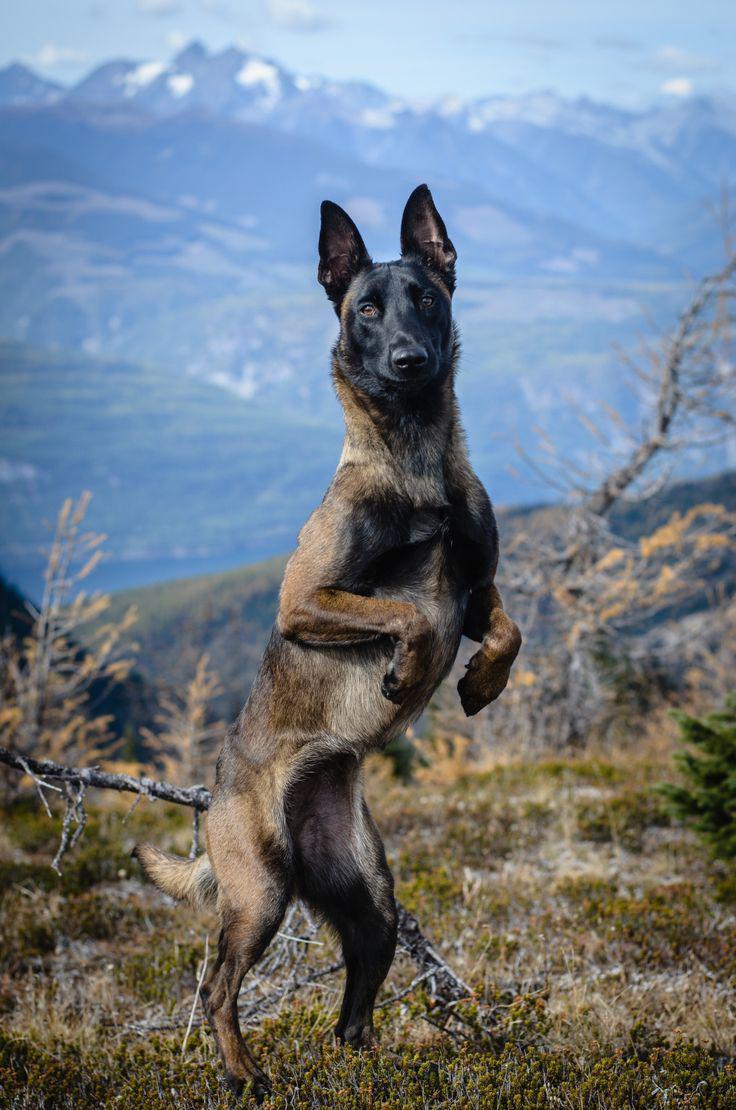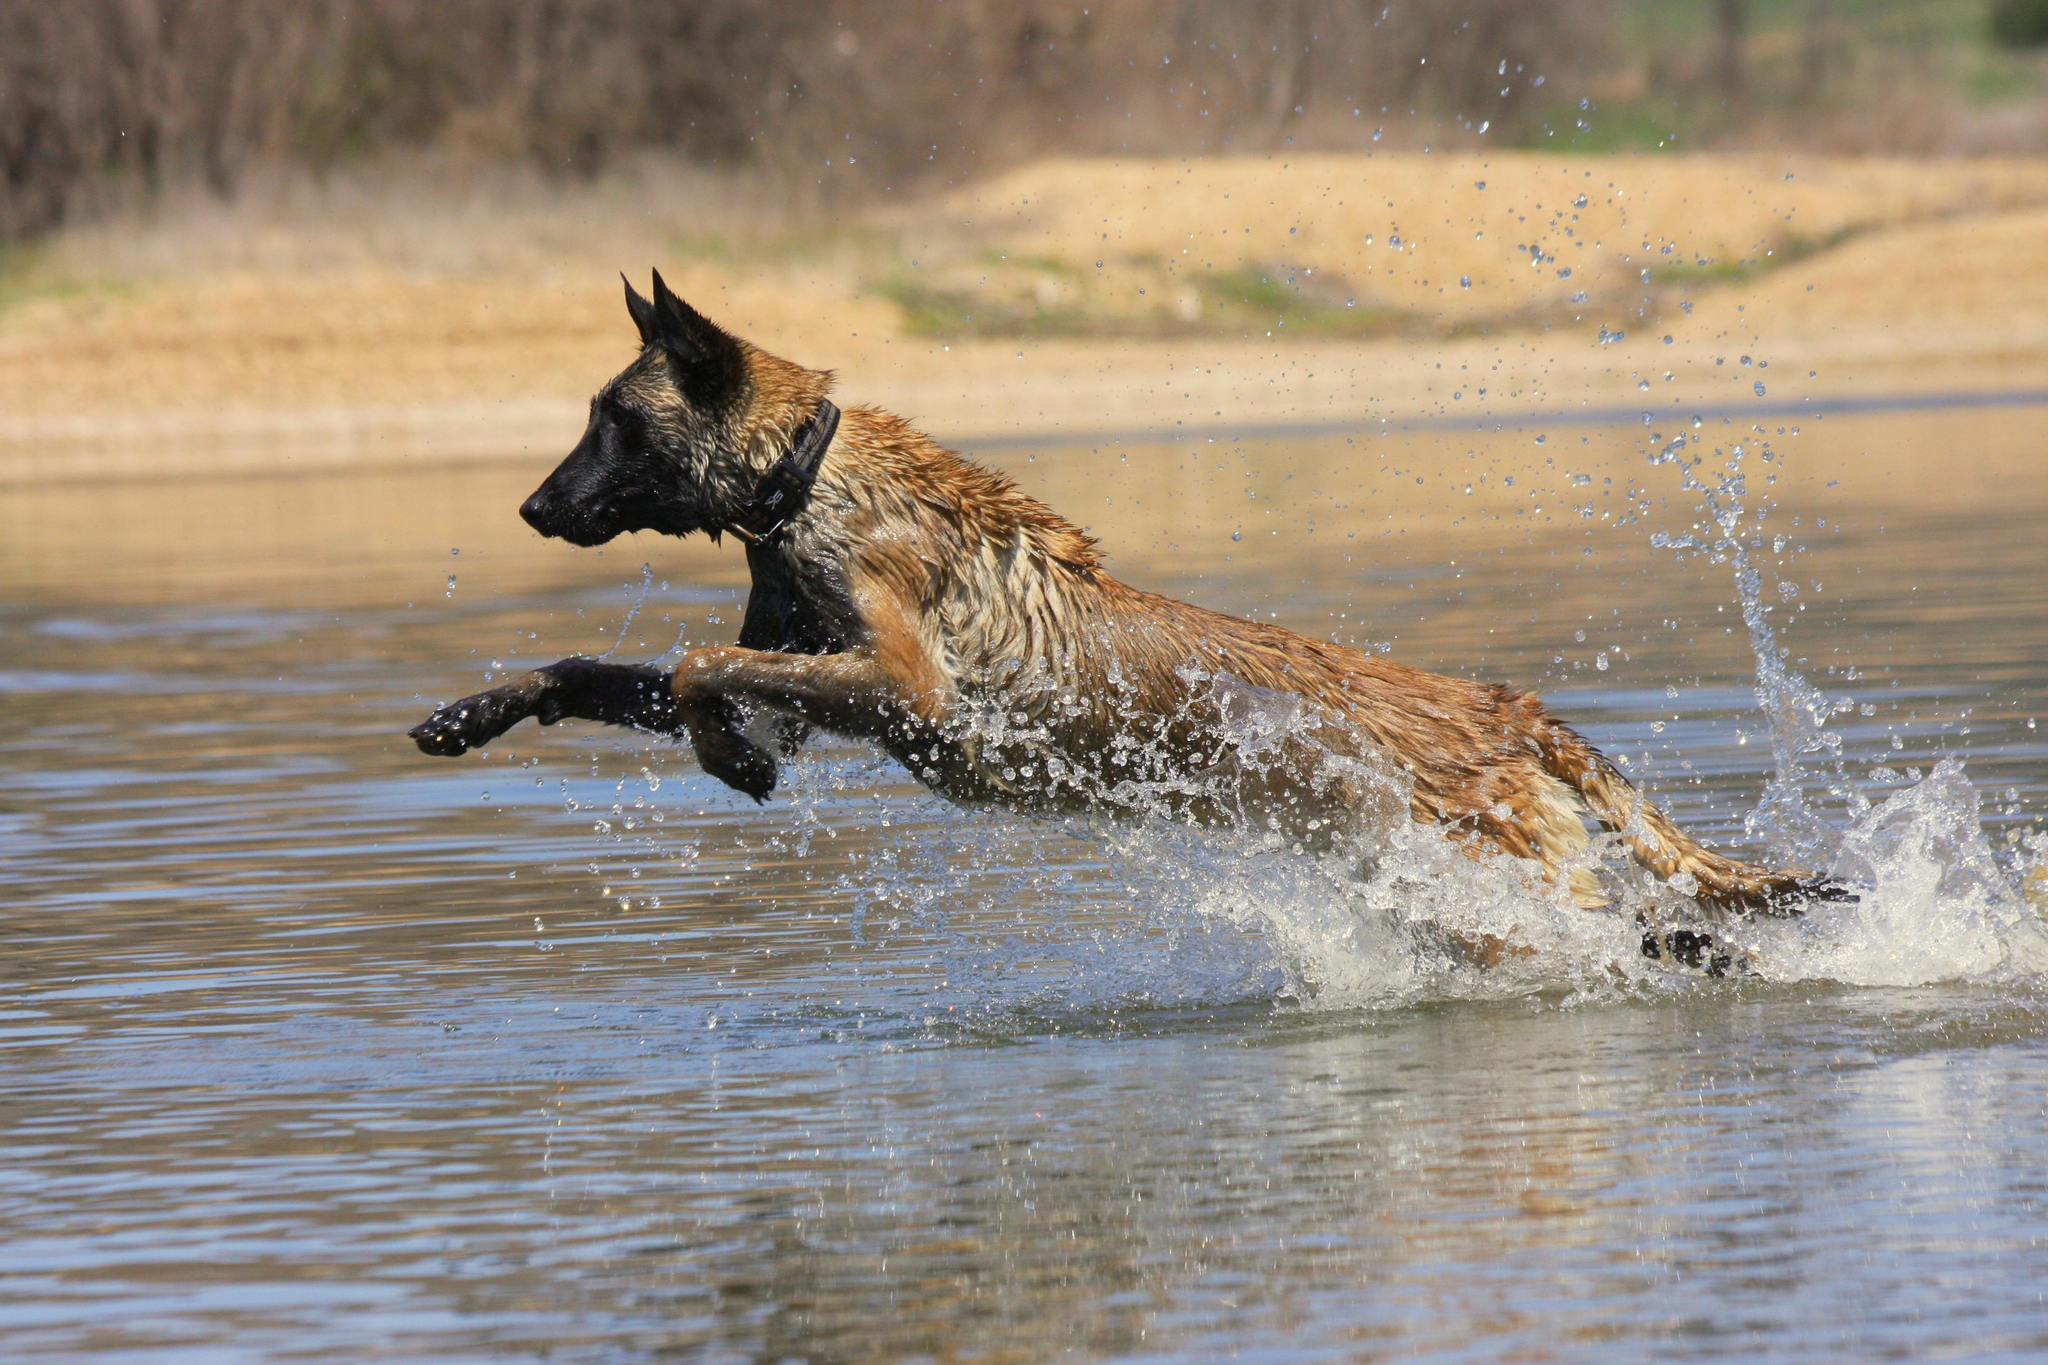The first image is the image on the left, the second image is the image on the right. For the images displayed, is the sentence "A dog is in a jumping pose splashing over water, facing leftward with front paws extended." factually correct? Answer yes or no. Yes. The first image is the image on the left, the second image is the image on the right. For the images shown, is this caption "An image contains a dog jumping in water." true? Answer yes or no. Yes. 